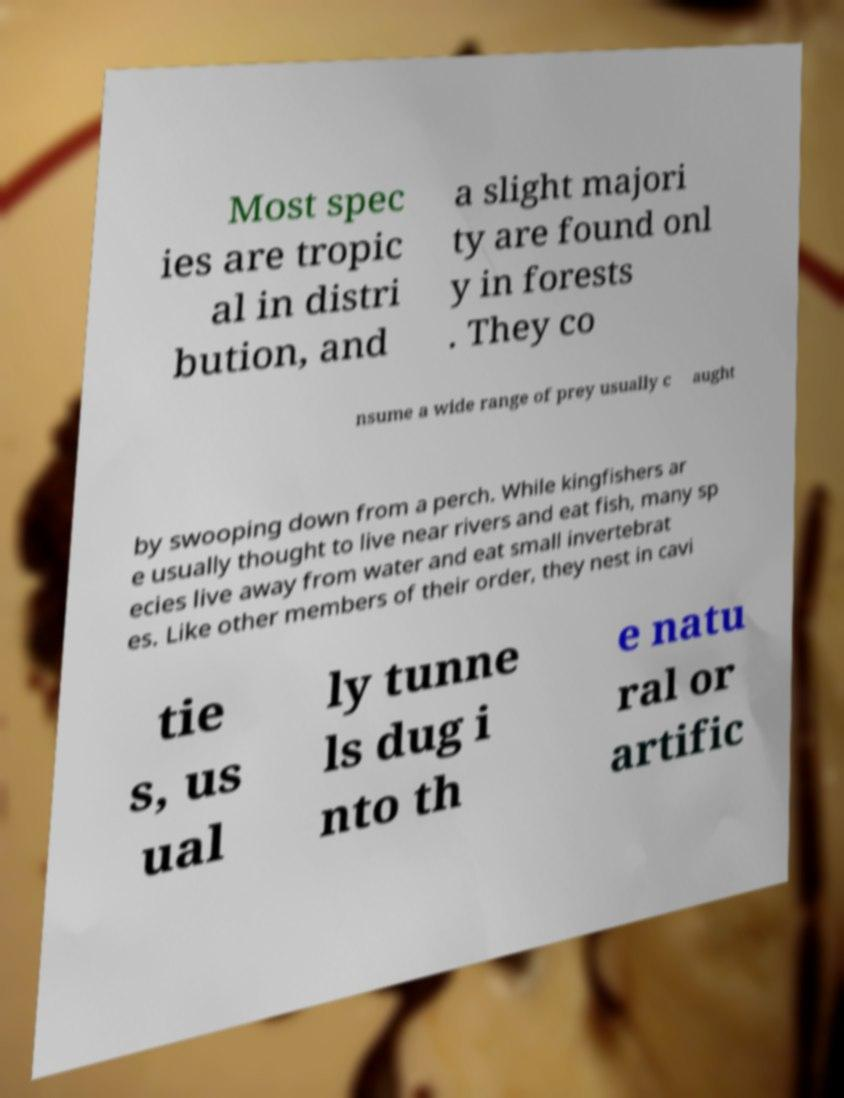Please read and relay the text visible in this image. What does it say? Most spec ies are tropic al in distri bution, and a slight majori ty are found onl y in forests . They co nsume a wide range of prey usually c aught by swooping down from a perch. While kingfishers ar e usually thought to live near rivers and eat fish, many sp ecies live away from water and eat small invertebrat es. Like other members of their order, they nest in cavi tie s, us ual ly tunne ls dug i nto th e natu ral or artific 